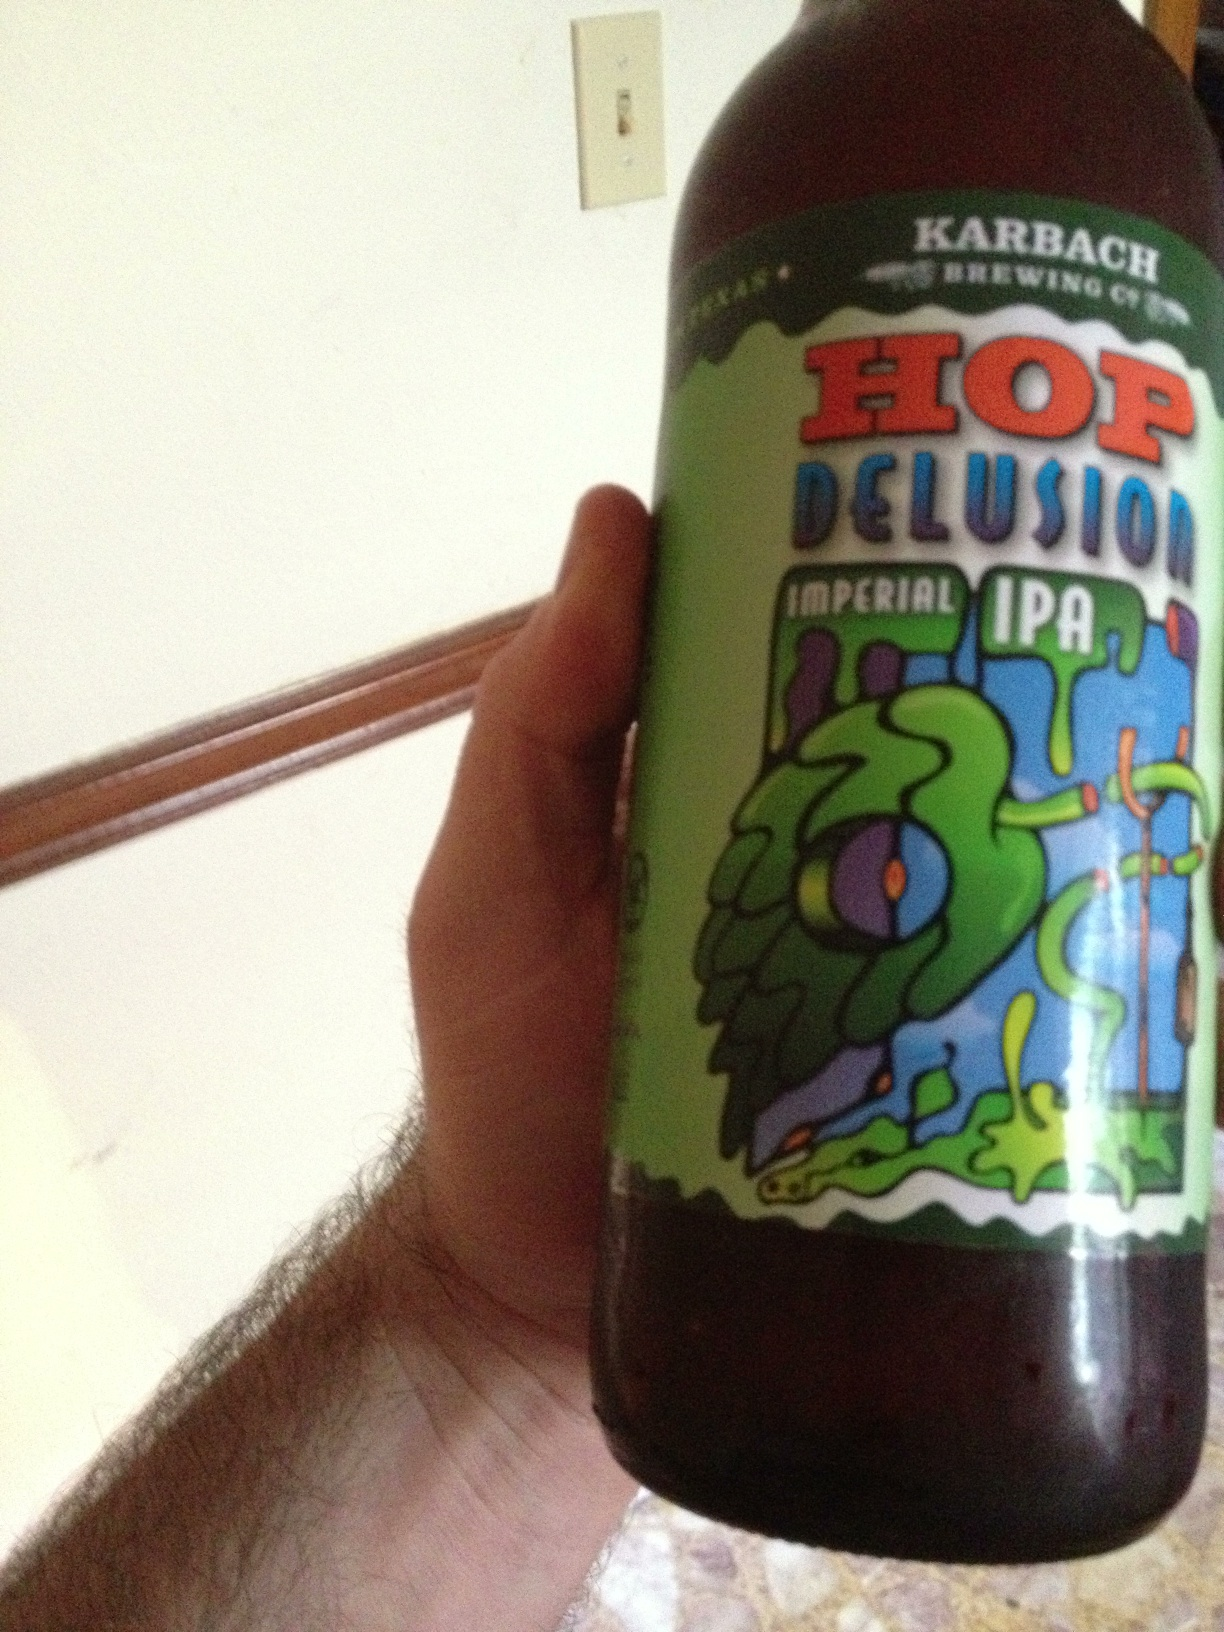Is there any food that pairs particularly well with this type of beer? Imperial IPAs like Hop Delusion pair wonderfully with rich, flavorful dishes such as spicy barbecue, blue cheese, and hearty burgers. The strong hop flavors can enhance and complement the boldness of these foods. 